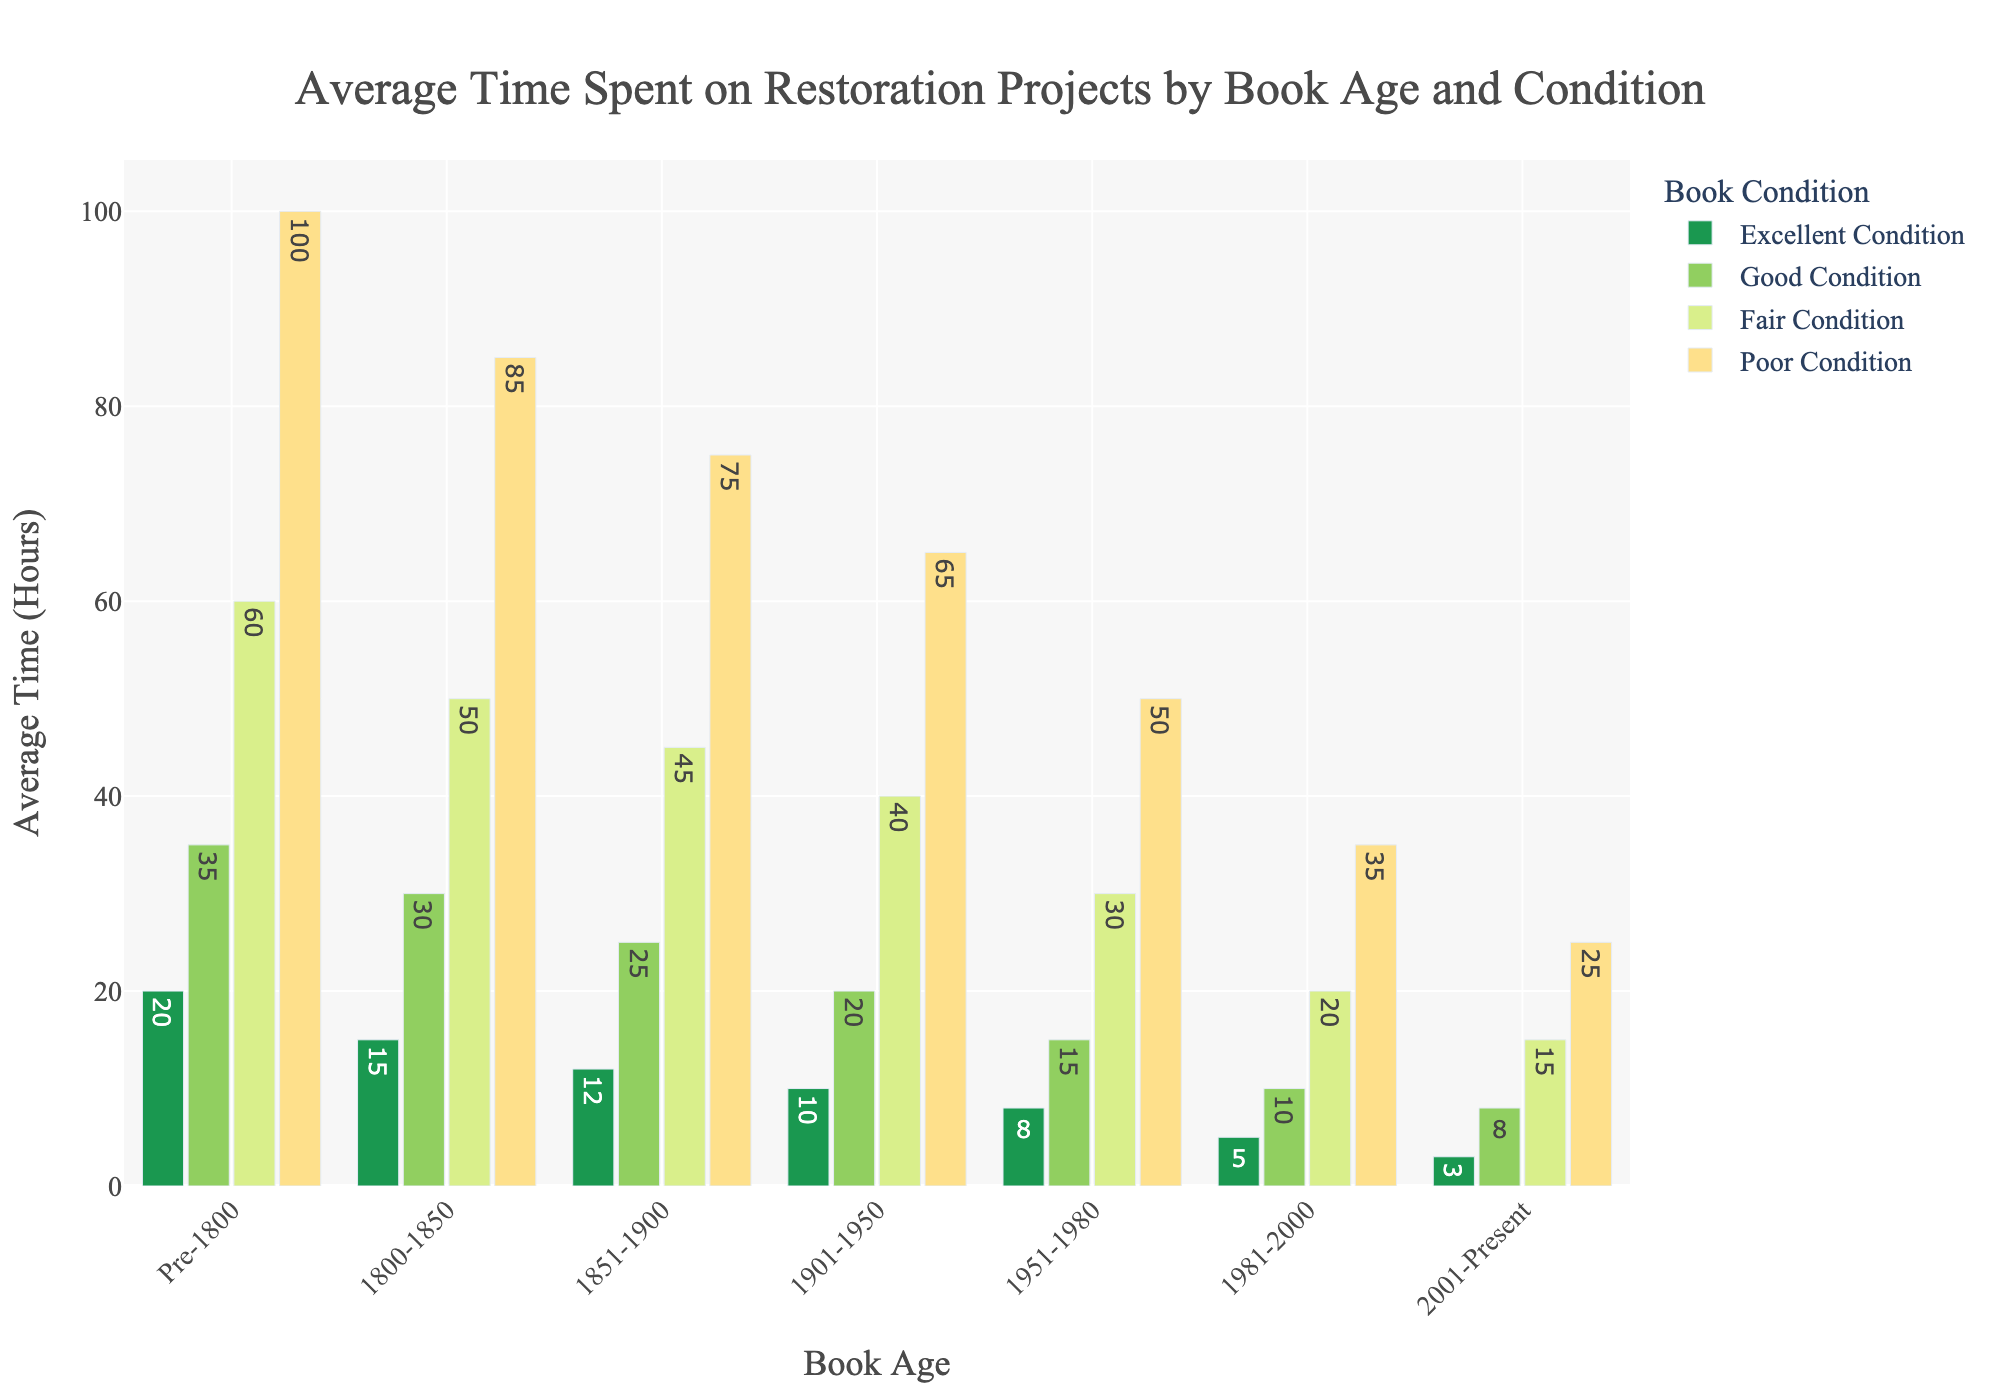How much more time is spent on restoring pre-1800 books in poor condition compared to 1901-1950 books in good condition? Look at the bar for pre-1800 books in poor condition, which shows 100 hours, and the bar for 1901-1950 books in good condition, which shows 20 hours. Subtract 20 from 100.
Answer: 80 hours What is the average restoration time for books in fair condition across all time periods? Look at the bars for fair condition: 60 (pre-1800), 50 (1800-1850), 45 (1851-1900), 40 (1901-1950), 30 (1951-1980), 20 (1981-2000), and 15 (2001-Present). The average is calculated by summing these values and dividing by the number of periods. (60 + 50 + 45 + 40 + 30 + 20 + 15) / 7 = 37.14 hours.
Answer: 37.14 hours Which book age group requires the least time for restoration in excellent condition? Look at the tallest bars for each book age group in excellent condition: 20 (pre-1800), 15 (1800-1850), 12 (1851-1900), 10 (1901-1950), 8 (1951-1980), 5 (1981-2000), and 3 (2001-Present). The smallest bar is for 2001-Present at 3 hours.
Answer: 2001-Present Which book condition shows the steepest increase in restoration time as the book age goes from 2001-Present to pre-1800? Compare the differences in bar heights for each condition. The increase for excellent is 3 to 20, good is 8 to 35, fair is 15 to 60, and poor is 25 to 100. The poorest condition shows an increase of 75 (100 - 25), which is the steepest.
Answer: Poor Condition How does the restoration time for books in good condition in the 1800-1850 period compare to those in poor condition in the 1981-2000 period? Look at the bar for 1800-1850 in good condition, which shows 30 hours, and the bar for 1981-2000 in poor condition, which shows 35 hours. The poor condition for 1981-2000 is 5 hours more than the good condition for 1800-1850.
Answer: 5 hours more What is the sum of the restoration times for 1951-1980 books in all conditions? Look at the bars for 1951-1980: 8 (excellent), 15 (good), 30 (fair), and 50 (poor). Sum these values: 8 + 15 + 30 + 50 = 103 hours.
Answer: 103 hours In which book age group does the restoration time for fair condition exceed that for good condition by the largest margin? Look at the differences between fair and good conditions for each age group: (pre-1800: 60-35=25), (1800-1850: 50-30=20), (1851-1900: 45-25=20), (1901-1950: 40-20=20), (1951-1980: 30-15=15), (1981-2000: 20-10=10), (2001-Present: 15-8=7). The largest margin is for pre-1800 which is 25.
Answer: Pre-1800 Which book age group has the smallest difference in restoration times between fair and poor conditions? Look at the differences between fair and poor conditions for each age group: (pre-1800: 100-60=40), (1800-1850: 85-50=35), (1851-1900: 75-45=30), (1901-1950: 65-40=25), (1951-1980: 50-30=20), (1981-2000: 35-20=15), (2001-Present: 25-15=10). The smallest difference is for 2001-Present which is 10.
Answer: 2001-Present What is the percentage increase in restoration time for poor condition books from 1901-1950 to pre-1800? Look at the bars for poor condition: 65 (1901-1950) and 100 (pre-1800). The increase is 100 - 65 = 35 hours. To find the percentage increase, calculate (35 / 65) * 100% = 53.85%.
Answer: 53.85% Compare the average restoration time for excellent condition books between the periods pre-1800 and 1800-1850. Look at the bars for excellent condition: 20 hours (pre-1800) and 15 hours (1800-1850). Sum these and divide by 2 to find the average: (20 + 15) / 2 = 17.5 hours.
Answer: 17.5 hours 